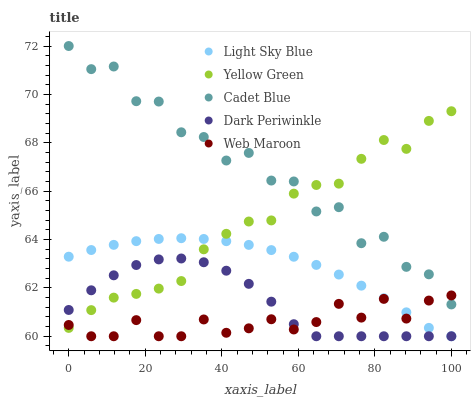Does Web Maroon have the minimum area under the curve?
Answer yes or no. Yes. Does Cadet Blue have the maximum area under the curve?
Answer yes or no. Yes. Does Light Sky Blue have the minimum area under the curve?
Answer yes or no. No. Does Light Sky Blue have the maximum area under the curve?
Answer yes or no. No. Is Light Sky Blue the smoothest?
Answer yes or no. Yes. Is Cadet Blue the roughest?
Answer yes or no. Yes. Is Web Maroon the smoothest?
Answer yes or no. No. Is Web Maroon the roughest?
Answer yes or no. No. Does Light Sky Blue have the lowest value?
Answer yes or no. Yes. Does Yellow Green have the lowest value?
Answer yes or no. No. Does Cadet Blue have the highest value?
Answer yes or no. Yes. Does Light Sky Blue have the highest value?
Answer yes or no. No. Is Light Sky Blue less than Cadet Blue?
Answer yes or no. Yes. Is Cadet Blue greater than Dark Periwinkle?
Answer yes or no. Yes. Does Cadet Blue intersect Web Maroon?
Answer yes or no. Yes. Is Cadet Blue less than Web Maroon?
Answer yes or no. No. Is Cadet Blue greater than Web Maroon?
Answer yes or no. No. Does Light Sky Blue intersect Cadet Blue?
Answer yes or no. No. 